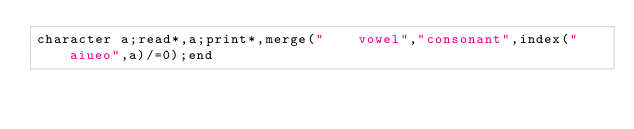<code> <loc_0><loc_0><loc_500><loc_500><_FORTRAN_>character a;read*,a;print*,merge("    vowel","consonant",index("aiueo",a)/=0);end</code> 